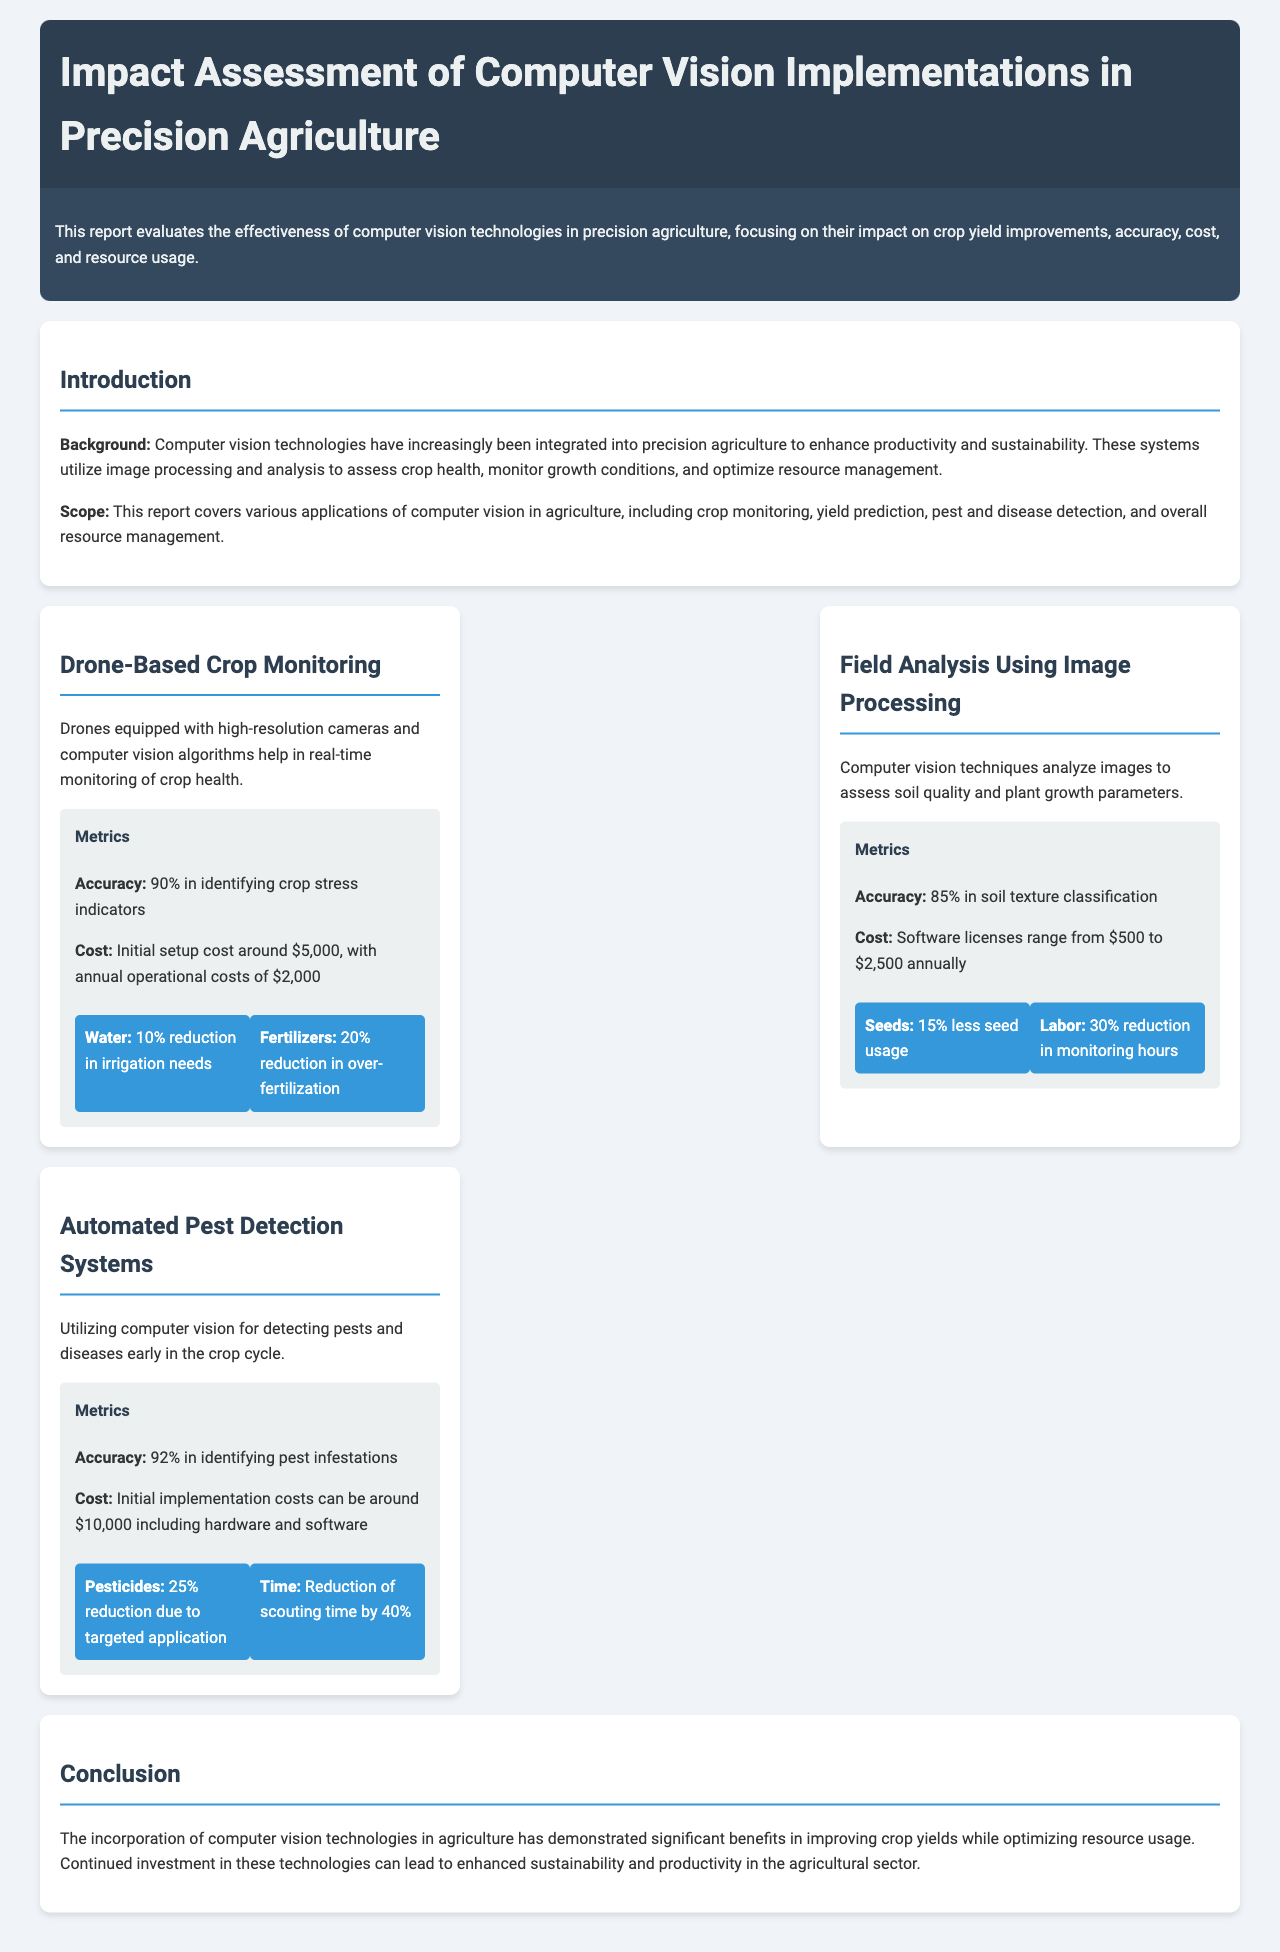What is the accuracy of drone-based crop monitoring? The accuracy of drone-based crop monitoring is stated as 90% in identifying crop stress indicators.
Answer: 90% What is the cost of implementing automated pest detection systems? The document mentions that initial implementation costs for automated pest detection systems can be around $10,000 including hardware and software.
Answer: $10,000 What percentage reduction in irrigation needs is observed with drone-based crop monitoring? It is indicated that drone-based crop monitoring results in a 10% reduction in irrigation needs.
Answer: 10% Which application has the highest accuracy in pest detection? The application of automated pest detection systems has an accuracy of 92% in identifying pest infestations, which is the highest mentioned in the report.
Answer: 92% What is the percentage reduction in monitoring hours provided by field analysis using image processing? The document states a 30% reduction in monitoring hours due to field analysis using image processing.
Answer: 30% What are the primary metrics evaluated in the report? The report evaluates metrics including accuracy, cost, and resource usage to analyze the effectiveness of computer vision technologies.
Answer: Accuracy, cost, resource usage How much can fertilizers be reduced with drone-based crop monitoring? The report states that there is a 20% reduction in over-fertilization when using drone-based crop monitoring.
Answer: 20% What is the annual operational cost of drone-based crop monitoring? The annual operational cost for drone-based crop monitoring is indicated to be $2,000.
Answer: $2,000 